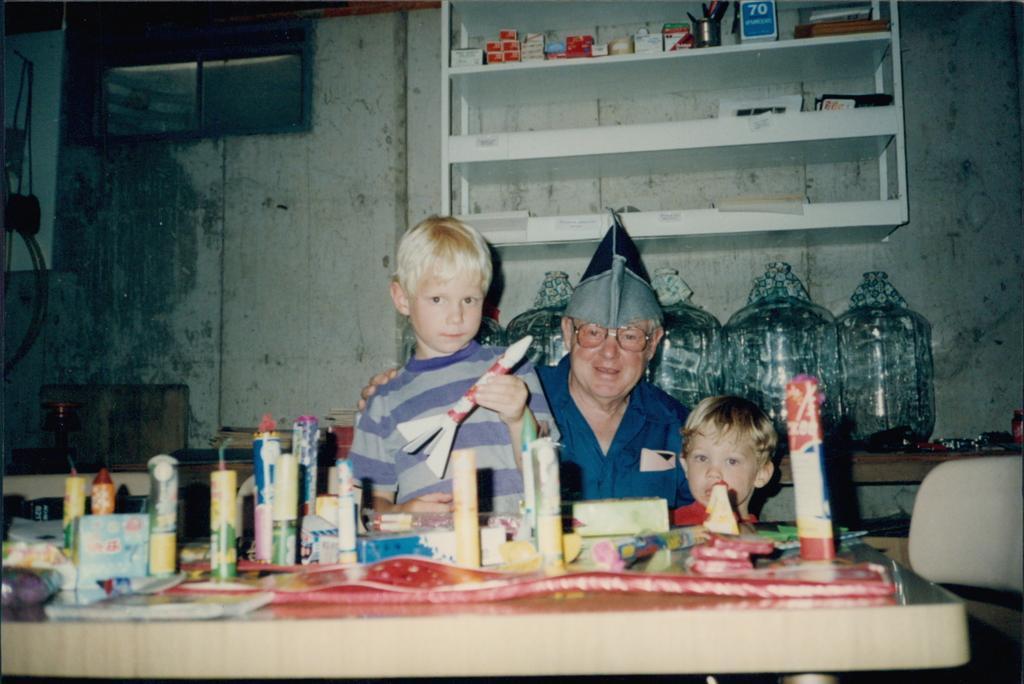Please provide a concise description of this image. In the image we can see there are people who are standing and on the table there are crackers kept on it. 